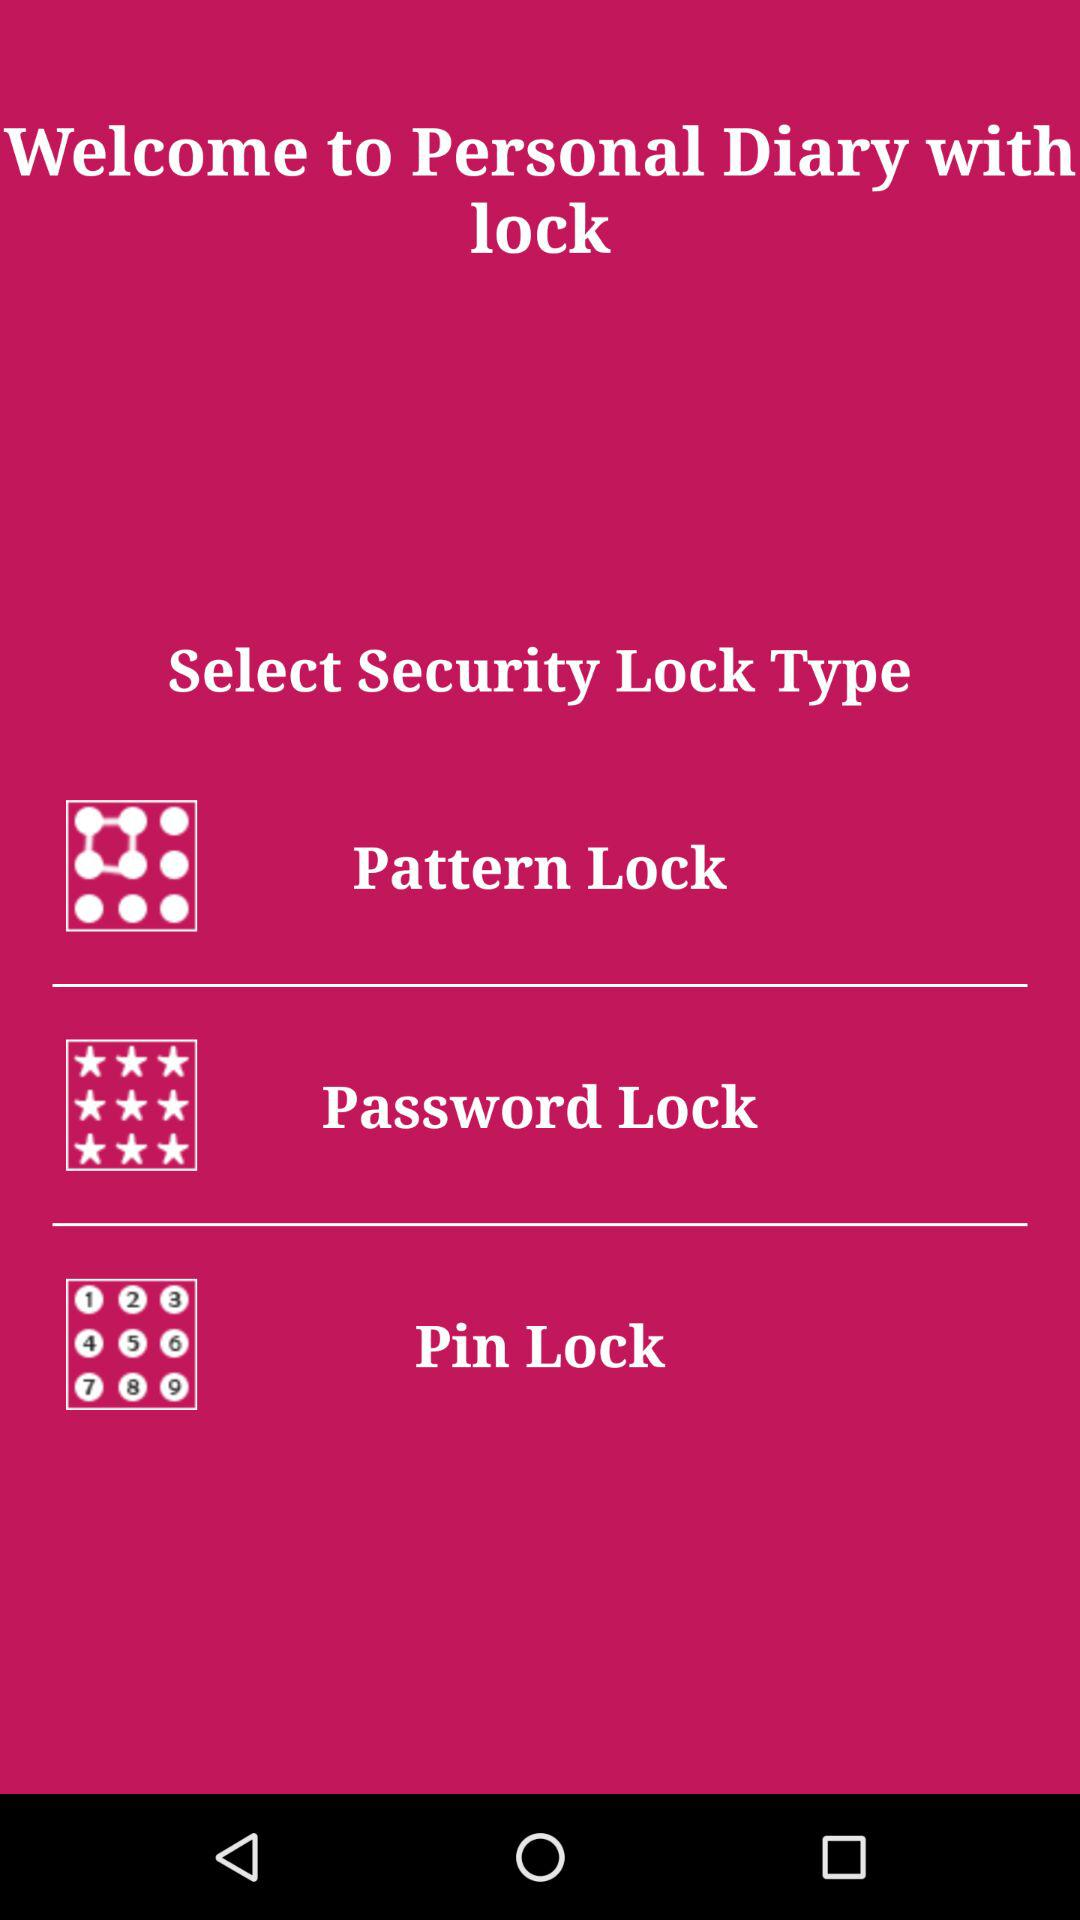Name the different types of security locks? The different types of security locks are "Pattern Lock", "Password Lock" and "Pin Lock". 